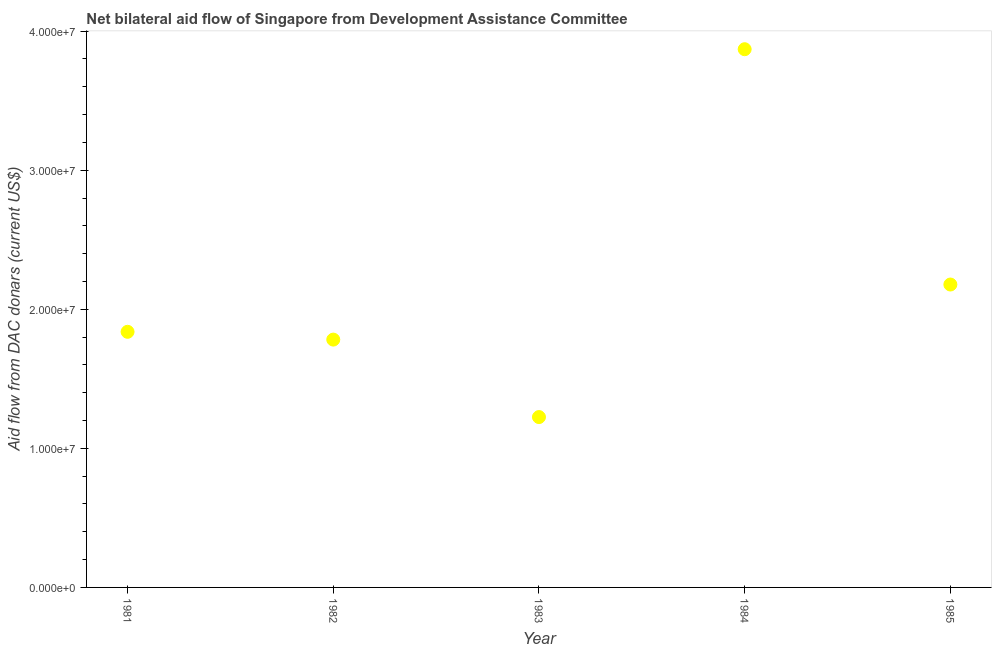What is the net bilateral aid flows from dac donors in 1984?
Offer a very short reply. 3.87e+07. Across all years, what is the maximum net bilateral aid flows from dac donors?
Offer a very short reply. 3.87e+07. Across all years, what is the minimum net bilateral aid flows from dac donors?
Make the answer very short. 1.22e+07. In which year was the net bilateral aid flows from dac donors maximum?
Offer a very short reply. 1984. What is the sum of the net bilateral aid flows from dac donors?
Provide a short and direct response. 1.09e+08. What is the difference between the net bilateral aid flows from dac donors in 1982 and 1983?
Provide a succinct answer. 5.57e+06. What is the average net bilateral aid flows from dac donors per year?
Offer a terse response. 2.18e+07. What is the median net bilateral aid flows from dac donors?
Provide a succinct answer. 1.84e+07. In how many years, is the net bilateral aid flows from dac donors greater than 36000000 US$?
Your answer should be very brief. 1. Do a majority of the years between 1983 and 1985 (inclusive) have net bilateral aid flows from dac donors greater than 38000000 US$?
Make the answer very short. No. What is the ratio of the net bilateral aid flows from dac donors in 1981 to that in 1982?
Provide a short and direct response. 1.03. What is the difference between the highest and the second highest net bilateral aid flows from dac donors?
Your answer should be compact. 1.69e+07. What is the difference between the highest and the lowest net bilateral aid flows from dac donors?
Make the answer very short. 2.64e+07. Does the net bilateral aid flows from dac donors monotonically increase over the years?
Your answer should be compact. No. How many dotlines are there?
Provide a short and direct response. 1. What is the difference between two consecutive major ticks on the Y-axis?
Provide a succinct answer. 1.00e+07. Are the values on the major ticks of Y-axis written in scientific E-notation?
Provide a short and direct response. Yes. What is the title of the graph?
Make the answer very short. Net bilateral aid flow of Singapore from Development Assistance Committee. What is the label or title of the Y-axis?
Keep it short and to the point. Aid flow from DAC donars (current US$). What is the Aid flow from DAC donars (current US$) in 1981?
Your response must be concise. 1.84e+07. What is the Aid flow from DAC donars (current US$) in 1982?
Provide a short and direct response. 1.78e+07. What is the Aid flow from DAC donars (current US$) in 1983?
Your response must be concise. 1.22e+07. What is the Aid flow from DAC donars (current US$) in 1984?
Provide a short and direct response. 3.87e+07. What is the Aid flow from DAC donars (current US$) in 1985?
Your answer should be very brief. 2.18e+07. What is the difference between the Aid flow from DAC donars (current US$) in 1981 and 1982?
Your answer should be compact. 5.60e+05. What is the difference between the Aid flow from DAC donars (current US$) in 1981 and 1983?
Your answer should be very brief. 6.13e+06. What is the difference between the Aid flow from DAC donars (current US$) in 1981 and 1984?
Keep it short and to the point. -2.03e+07. What is the difference between the Aid flow from DAC donars (current US$) in 1981 and 1985?
Offer a terse response. -3.40e+06. What is the difference between the Aid flow from DAC donars (current US$) in 1982 and 1983?
Keep it short and to the point. 5.57e+06. What is the difference between the Aid flow from DAC donars (current US$) in 1982 and 1984?
Your response must be concise. -2.09e+07. What is the difference between the Aid flow from DAC donars (current US$) in 1982 and 1985?
Your answer should be very brief. -3.96e+06. What is the difference between the Aid flow from DAC donars (current US$) in 1983 and 1984?
Give a very brief answer. -2.64e+07. What is the difference between the Aid flow from DAC donars (current US$) in 1983 and 1985?
Your answer should be very brief. -9.53e+06. What is the difference between the Aid flow from DAC donars (current US$) in 1984 and 1985?
Your answer should be compact. 1.69e+07. What is the ratio of the Aid flow from DAC donars (current US$) in 1981 to that in 1982?
Your answer should be very brief. 1.03. What is the ratio of the Aid flow from DAC donars (current US$) in 1981 to that in 1983?
Your answer should be compact. 1.5. What is the ratio of the Aid flow from DAC donars (current US$) in 1981 to that in 1984?
Offer a very short reply. 0.47. What is the ratio of the Aid flow from DAC donars (current US$) in 1981 to that in 1985?
Give a very brief answer. 0.84. What is the ratio of the Aid flow from DAC donars (current US$) in 1982 to that in 1983?
Make the answer very short. 1.46. What is the ratio of the Aid flow from DAC donars (current US$) in 1982 to that in 1984?
Provide a succinct answer. 0.46. What is the ratio of the Aid flow from DAC donars (current US$) in 1982 to that in 1985?
Offer a very short reply. 0.82. What is the ratio of the Aid flow from DAC donars (current US$) in 1983 to that in 1984?
Provide a short and direct response. 0.32. What is the ratio of the Aid flow from DAC donars (current US$) in 1983 to that in 1985?
Ensure brevity in your answer.  0.56. What is the ratio of the Aid flow from DAC donars (current US$) in 1984 to that in 1985?
Give a very brief answer. 1.78. 